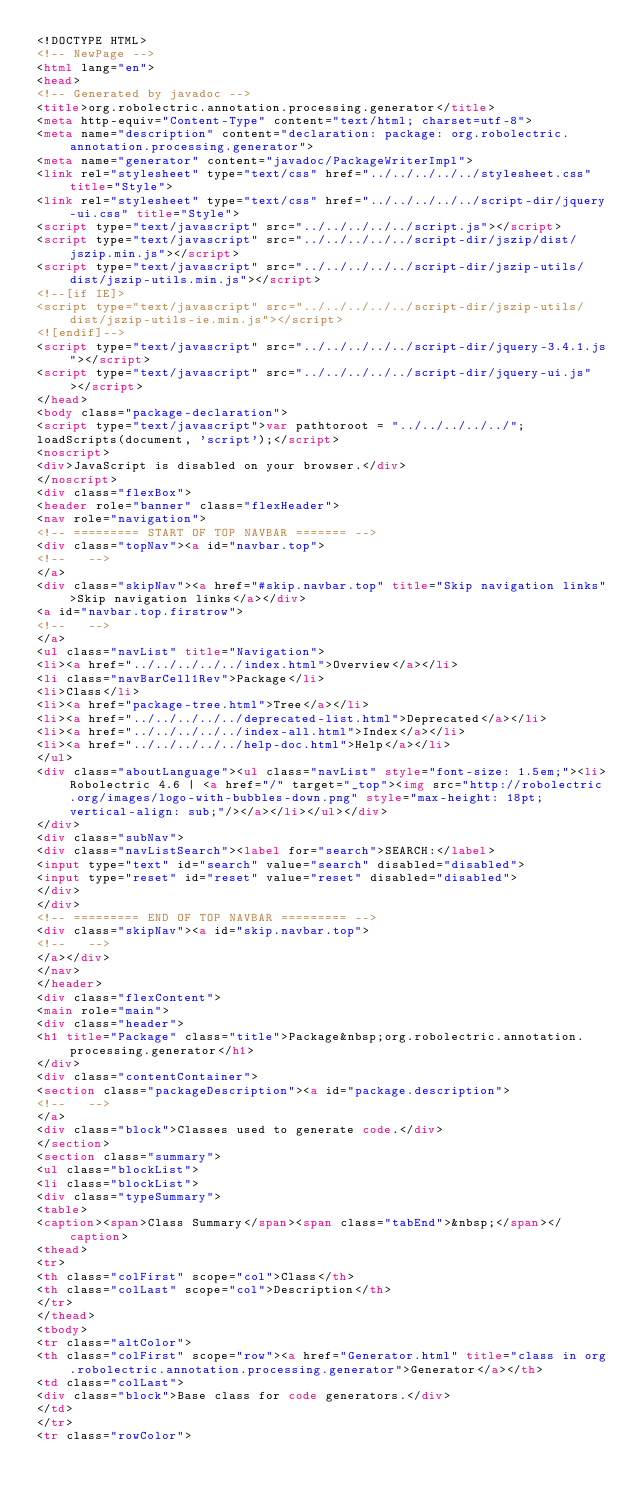Convert code to text. <code><loc_0><loc_0><loc_500><loc_500><_HTML_><!DOCTYPE HTML>
<!-- NewPage -->
<html lang="en">
<head>
<!-- Generated by javadoc -->
<title>org.robolectric.annotation.processing.generator</title>
<meta http-equiv="Content-Type" content="text/html; charset=utf-8">
<meta name="description" content="declaration: package: org.robolectric.annotation.processing.generator">
<meta name="generator" content="javadoc/PackageWriterImpl">
<link rel="stylesheet" type="text/css" href="../../../../../stylesheet.css" title="Style">
<link rel="stylesheet" type="text/css" href="../../../../../script-dir/jquery-ui.css" title="Style">
<script type="text/javascript" src="../../../../../script.js"></script>
<script type="text/javascript" src="../../../../../script-dir/jszip/dist/jszip.min.js"></script>
<script type="text/javascript" src="../../../../../script-dir/jszip-utils/dist/jszip-utils.min.js"></script>
<!--[if IE]>
<script type="text/javascript" src="../../../../../script-dir/jszip-utils/dist/jszip-utils-ie.min.js"></script>
<![endif]-->
<script type="text/javascript" src="../../../../../script-dir/jquery-3.4.1.js"></script>
<script type="text/javascript" src="../../../../../script-dir/jquery-ui.js"></script>
</head>
<body class="package-declaration">
<script type="text/javascript">var pathtoroot = "../../../../../";
loadScripts(document, 'script');</script>
<noscript>
<div>JavaScript is disabled on your browser.</div>
</noscript>
<div class="flexBox">
<header role="banner" class="flexHeader">
<nav role="navigation">
<!-- ========= START OF TOP NAVBAR ======= -->
<div class="topNav"><a id="navbar.top">
<!--   -->
</a>
<div class="skipNav"><a href="#skip.navbar.top" title="Skip navigation links">Skip navigation links</a></div>
<a id="navbar.top.firstrow">
<!--   -->
</a>
<ul class="navList" title="Navigation">
<li><a href="../../../../../index.html">Overview</a></li>
<li class="navBarCell1Rev">Package</li>
<li>Class</li>
<li><a href="package-tree.html">Tree</a></li>
<li><a href="../../../../../deprecated-list.html">Deprecated</a></li>
<li><a href="../../../../../index-all.html">Index</a></li>
<li><a href="../../../../../help-doc.html">Help</a></li>
</ul>
<div class="aboutLanguage"><ul class="navList" style="font-size: 1.5em;"><li>Robolectric 4.6 | <a href="/" target="_top"><img src="http://robolectric.org/images/logo-with-bubbles-down.png" style="max-height: 18pt; vertical-align: sub;"/></a></li></ul></div>
</div>
<div class="subNav">
<div class="navListSearch"><label for="search">SEARCH:</label>
<input type="text" id="search" value="search" disabled="disabled">
<input type="reset" id="reset" value="reset" disabled="disabled">
</div>
</div>
<!-- ========= END OF TOP NAVBAR ========= -->
<div class="skipNav"><a id="skip.navbar.top">
<!--   -->
</a></div>
</nav>
</header>
<div class="flexContent">
<main role="main">
<div class="header">
<h1 title="Package" class="title">Package&nbsp;org.robolectric.annotation.processing.generator</h1>
</div>
<div class="contentContainer">
<section class="packageDescription"><a id="package.description">
<!--   -->
</a>
<div class="block">Classes used to generate code.</div>
</section>
<section class="summary">
<ul class="blockList">
<li class="blockList">
<div class="typeSummary">
<table>
<caption><span>Class Summary</span><span class="tabEnd">&nbsp;</span></caption>
<thead>
<tr>
<th class="colFirst" scope="col">Class</th>
<th class="colLast" scope="col">Description</th>
</tr>
</thead>
<tbody>
<tr class="altColor">
<th class="colFirst" scope="row"><a href="Generator.html" title="class in org.robolectric.annotation.processing.generator">Generator</a></th>
<td class="colLast">
<div class="block">Base class for code generators.</div>
</td>
</tr>
<tr class="rowColor"></code> 